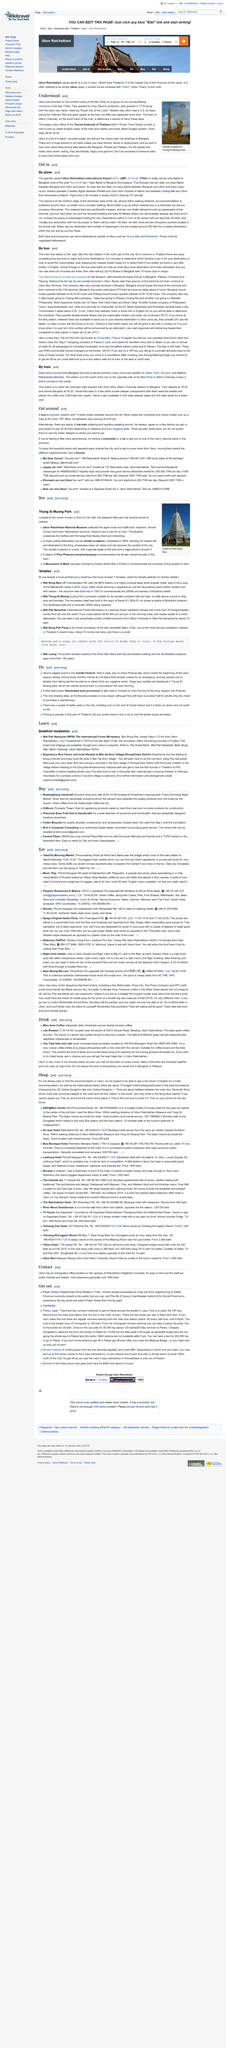Indicate a few pertinent items in this graphic. The Tourist Authority of Thailand is a valuable resource worth visiting for those seeking to enhance their English language skills and obtain comprehensive maps of the town and surrounding regions. Ubon, a city located in the northern bank of the Mun River, was founded. According to "Understand," Ubon was founded by a group of Lao princes who fled Vientiane. 